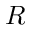<formula> <loc_0><loc_0><loc_500><loc_500>R</formula> 